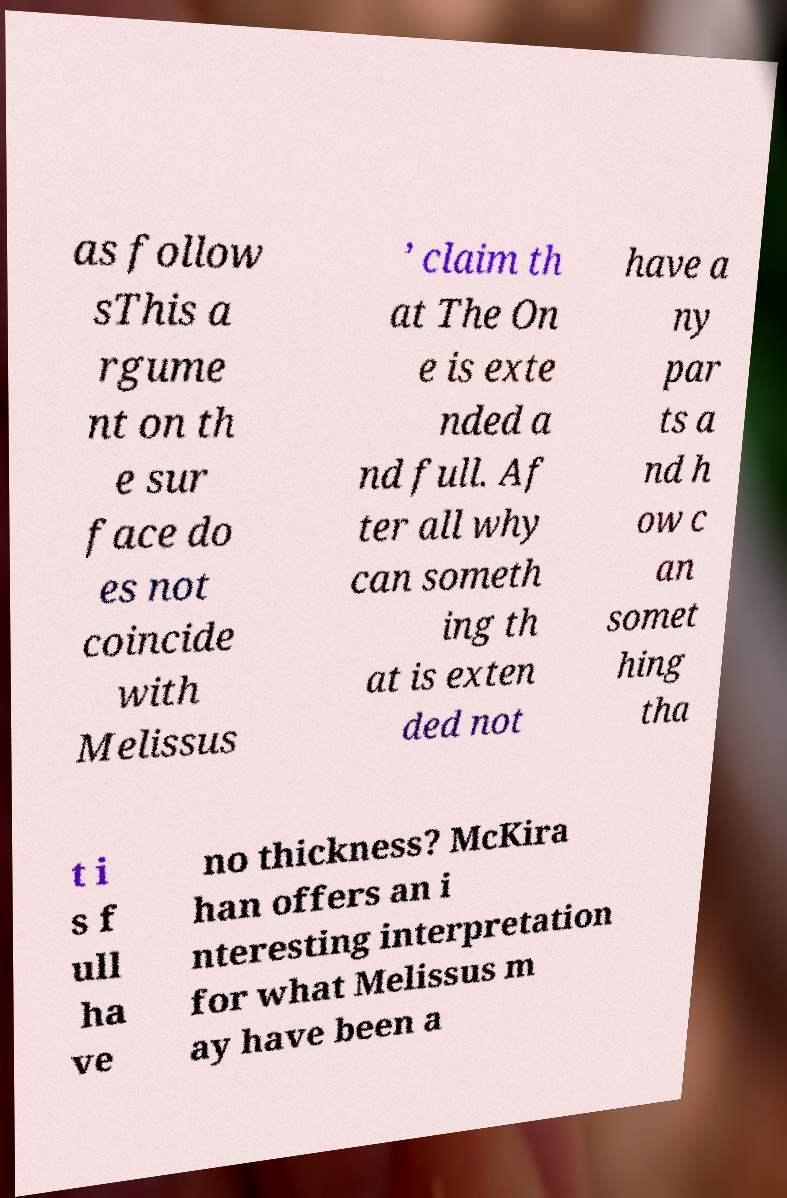Can you accurately transcribe the text from the provided image for me? as follow sThis a rgume nt on th e sur face do es not coincide with Melissus ’ claim th at The On e is exte nded a nd full. Af ter all why can someth ing th at is exten ded not have a ny par ts a nd h ow c an somet hing tha t i s f ull ha ve no thickness? McKira han offers an i nteresting interpretation for what Melissus m ay have been a 